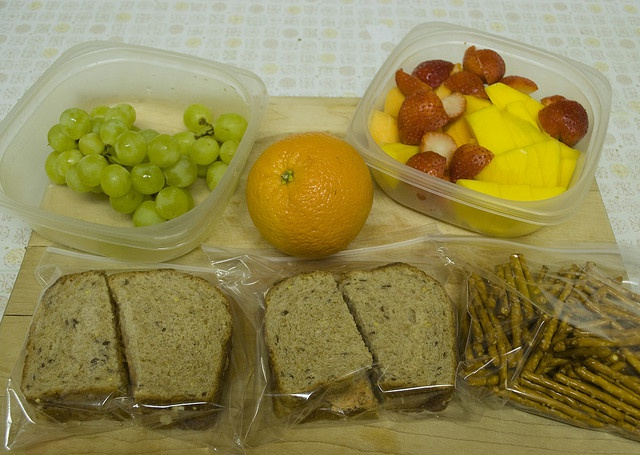Describe the objects in this image and their specific colors. I can see dining table in darkgray and lightgray tones, bowl in darkgray, olive, tan, and maroon tones, bowl in darkgray and olive tones, sandwich in darkgray and olive tones, and sandwich in darkgray, olive, and black tones in this image. 